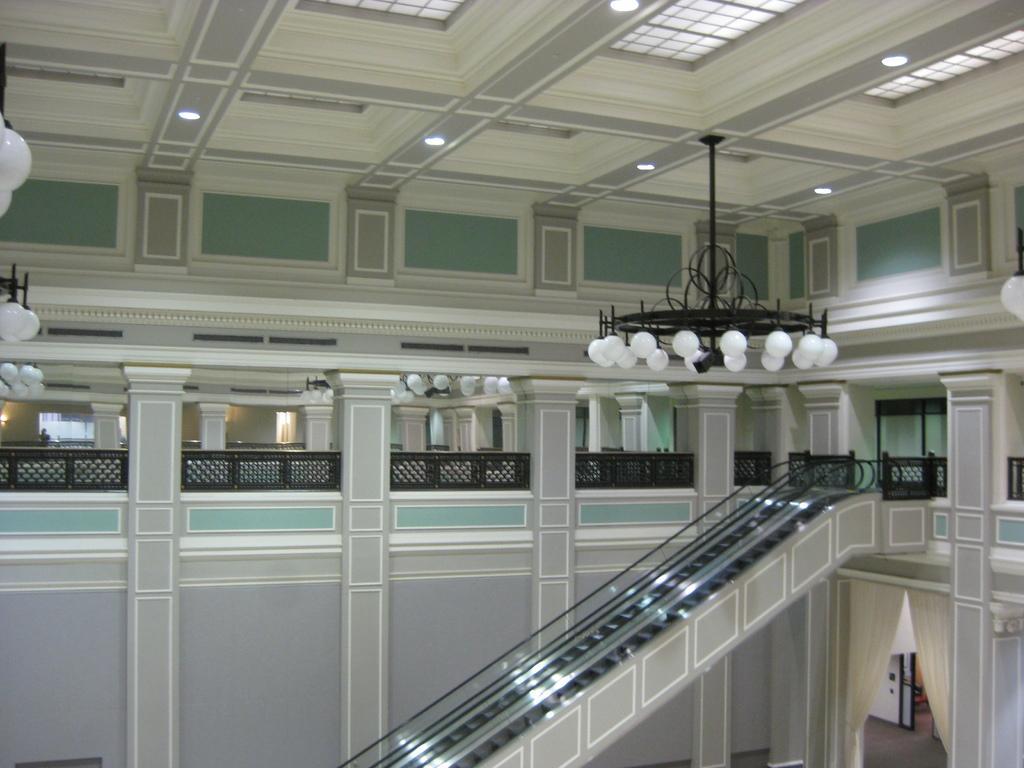Can you describe this image briefly? This is an inside view of a building. At the bottom there is an escalator. In the middle of the image I can see the railings. At the top there are few lights and there are few chandeliers hanging to the roof. 